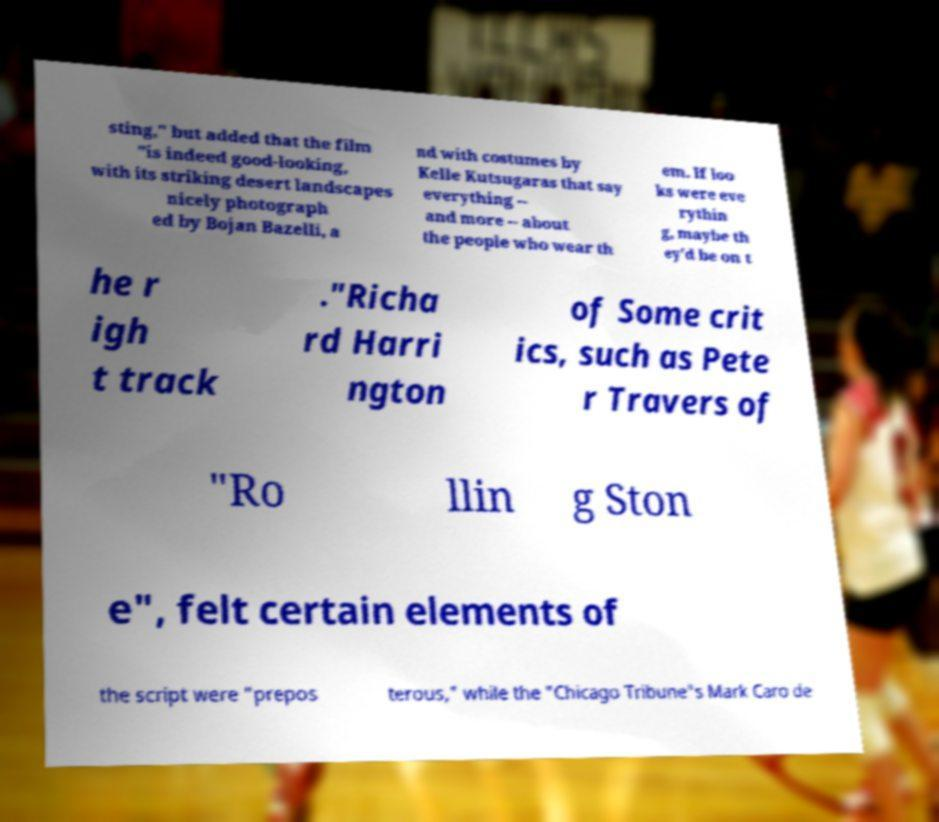Can you read and provide the text displayed in the image?This photo seems to have some interesting text. Can you extract and type it out for me? sting," but added that the film "is indeed good-looking, with its striking desert landscapes nicely photograph ed by Bojan Bazelli, a nd with costumes by Kelle Kutsugaras that say everything -- and more -- about the people who wear th em. If loo ks were eve rythin g, maybe th ey'd be on t he r igh t track ."Richa rd Harri ngton of Some crit ics, such as Pete r Travers of "Ro llin g Ston e", felt certain elements of the script were "prepos terous," while the "Chicago Tribune"s Mark Caro de 